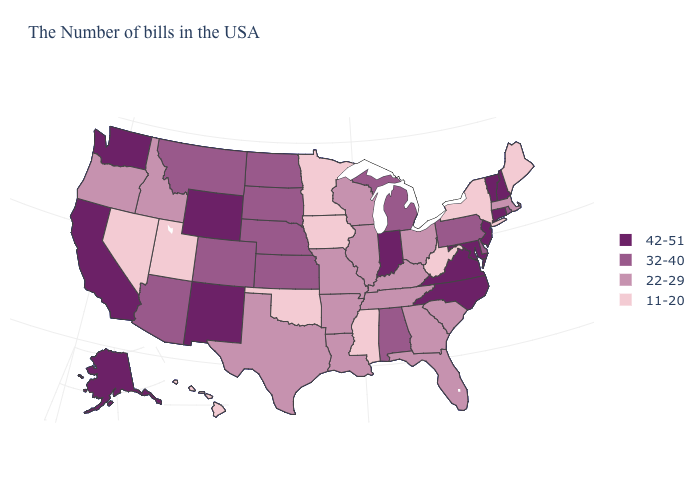Name the states that have a value in the range 42-51?
Keep it brief. New Hampshire, Vermont, Connecticut, New Jersey, Maryland, Virginia, North Carolina, Indiana, Wyoming, New Mexico, California, Washington, Alaska. What is the value of New York?
Concise answer only. 11-20. How many symbols are there in the legend?
Write a very short answer. 4. Does Massachusetts have the highest value in the Northeast?
Short answer required. No. What is the lowest value in states that border Nevada?
Give a very brief answer. 11-20. Is the legend a continuous bar?
Quick response, please. No. Which states hav the highest value in the MidWest?
Concise answer only. Indiana. Does the map have missing data?
Quick response, please. No. Is the legend a continuous bar?
Be succinct. No. Name the states that have a value in the range 11-20?
Concise answer only. Maine, New York, West Virginia, Mississippi, Minnesota, Iowa, Oklahoma, Utah, Nevada, Hawaii. What is the value of Missouri?
Short answer required. 22-29. How many symbols are there in the legend?
Answer briefly. 4. Does Idaho have a lower value than Alaska?
Quick response, please. Yes. Name the states that have a value in the range 11-20?
Write a very short answer. Maine, New York, West Virginia, Mississippi, Minnesota, Iowa, Oklahoma, Utah, Nevada, Hawaii. 